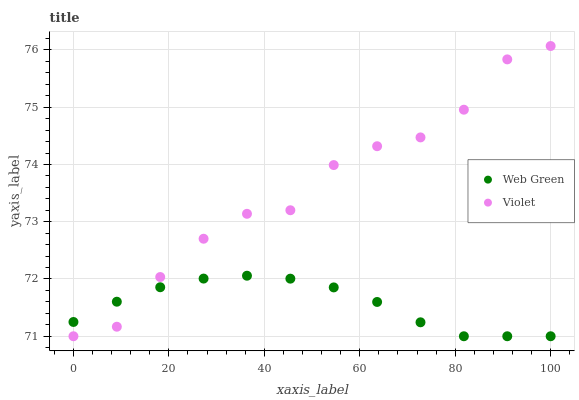Does Web Green have the minimum area under the curve?
Answer yes or no. Yes. Does Violet have the maximum area under the curve?
Answer yes or no. Yes. Does Violet have the minimum area under the curve?
Answer yes or no. No. Is Web Green the smoothest?
Answer yes or no. Yes. Is Violet the roughest?
Answer yes or no. Yes. Is Violet the smoothest?
Answer yes or no. No. Does Web Green have the lowest value?
Answer yes or no. Yes. Does Violet have the highest value?
Answer yes or no. Yes. Does Web Green intersect Violet?
Answer yes or no. Yes. Is Web Green less than Violet?
Answer yes or no. No. Is Web Green greater than Violet?
Answer yes or no. No. 